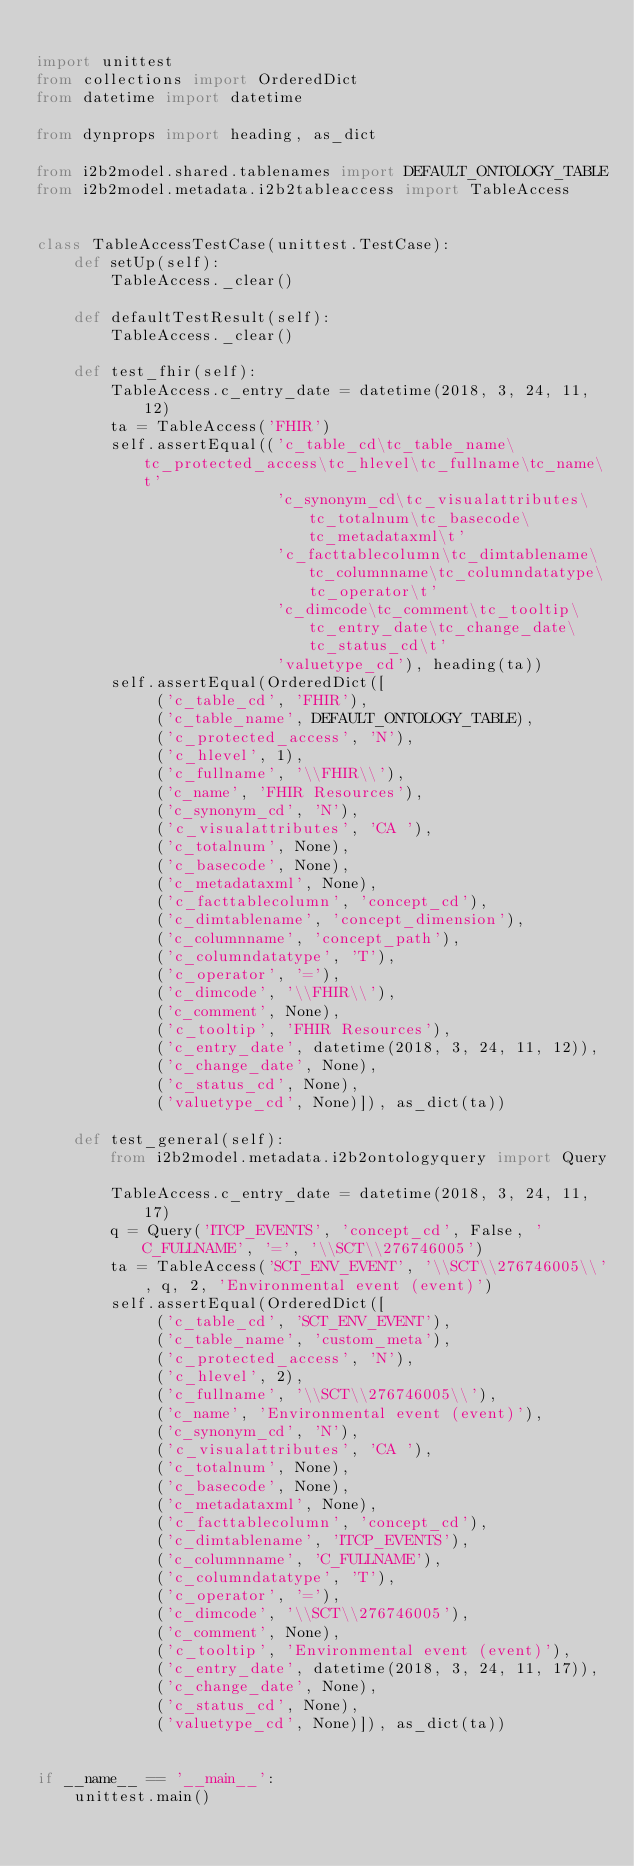<code> <loc_0><loc_0><loc_500><loc_500><_Python_>
import unittest
from collections import OrderedDict
from datetime import datetime

from dynprops import heading, as_dict

from i2b2model.shared.tablenames import DEFAULT_ONTOLOGY_TABLE
from i2b2model.metadata.i2b2tableaccess import TableAccess


class TableAccessTestCase(unittest.TestCase):
    def setUp(self):
        TableAccess._clear()

    def defaultTestResult(self):
        TableAccess._clear()

    def test_fhir(self):
        TableAccess.c_entry_date = datetime(2018, 3, 24, 11, 12)
        ta = TableAccess('FHIR')
        self.assertEqual(('c_table_cd\tc_table_name\tc_protected_access\tc_hlevel\tc_fullname\tc_name\t'
                          'c_synonym_cd\tc_visualattributes\tc_totalnum\tc_basecode\tc_metadataxml\t'
                          'c_facttablecolumn\tc_dimtablename\tc_columnname\tc_columndatatype\tc_operator\t'
                          'c_dimcode\tc_comment\tc_tooltip\tc_entry_date\tc_change_date\tc_status_cd\t'
                          'valuetype_cd'), heading(ta))
        self.assertEqual(OrderedDict([
             ('c_table_cd', 'FHIR'),
             ('c_table_name', DEFAULT_ONTOLOGY_TABLE),
             ('c_protected_access', 'N'),
             ('c_hlevel', 1),
             ('c_fullname', '\\FHIR\\'),
             ('c_name', 'FHIR Resources'),
             ('c_synonym_cd', 'N'),
             ('c_visualattributes', 'CA '),
             ('c_totalnum', None),
             ('c_basecode', None),
             ('c_metadataxml', None),
             ('c_facttablecolumn', 'concept_cd'),
             ('c_dimtablename', 'concept_dimension'),
             ('c_columnname', 'concept_path'),
             ('c_columndatatype', 'T'),
             ('c_operator', '='),
             ('c_dimcode', '\\FHIR\\'),
             ('c_comment', None),
             ('c_tooltip', 'FHIR Resources'),
             ('c_entry_date', datetime(2018, 3, 24, 11, 12)),
             ('c_change_date', None),
             ('c_status_cd', None),
             ('valuetype_cd', None)]), as_dict(ta))

    def test_general(self):
        from i2b2model.metadata.i2b2ontologyquery import Query

        TableAccess.c_entry_date = datetime(2018, 3, 24, 11, 17)
        q = Query('ITCP_EVENTS', 'concept_cd', False, 'C_FULLNAME', '=', '\\SCT\\276746005')
        ta = TableAccess('SCT_ENV_EVENT', '\\SCT\\276746005\\', q, 2, 'Environmental event (event)')
        self.assertEqual(OrderedDict([
             ('c_table_cd', 'SCT_ENV_EVENT'),
             ('c_table_name', 'custom_meta'),
             ('c_protected_access', 'N'),
             ('c_hlevel', 2),
             ('c_fullname', '\\SCT\\276746005\\'),
             ('c_name', 'Environmental event (event)'),
             ('c_synonym_cd', 'N'),
             ('c_visualattributes', 'CA '),
             ('c_totalnum', None),
             ('c_basecode', None),
             ('c_metadataxml', None),
             ('c_facttablecolumn', 'concept_cd'),
             ('c_dimtablename', 'ITCP_EVENTS'),
             ('c_columnname', 'C_FULLNAME'),
             ('c_columndatatype', 'T'),
             ('c_operator', '='),
             ('c_dimcode', '\\SCT\\276746005'),
             ('c_comment', None),
             ('c_tooltip', 'Environmental event (event)'),
             ('c_entry_date', datetime(2018, 3, 24, 11, 17)),
             ('c_change_date', None),
             ('c_status_cd', None),
             ('valuetype_cd', None)]), as_dict(ta))


if __name__ == '__main__':
    unittest.main()
</code> 